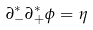<formula> <loc_0><loc_0><loc_500><loc_500>\partial _ { - } ^ { \ast } \partial _ { + } ^ { \ast } \phi = \eta</formula> 